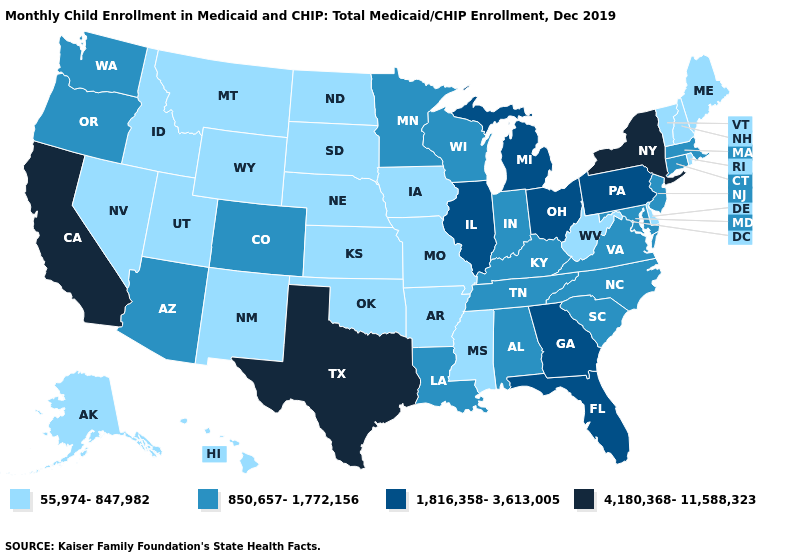Name the states that have a value in the range 4,180,368-11,588,323?
Quick response, please. California, New York, Texas. Which states have the highest value in the USA?
Short answer required. California, New York, Texas. Name the states that have a value in the range 1,816,358-3,613,005?
Quick response, please. Florida, Georgia, Illinois, Michigan, Ohio, Pennsylvania. Name the states that have a value in the range 4,180,368-11,588,323?
Give a very brief answer. California, New York, Texas. Among the states that border Utah , which have the lowest value?
Keep it brief. Idaho, Nevada, New Mexico, Wyoming. Name the states that have a value in the range 55,974-847,982?
Concise answer only. Alaska, Arkansas, Delaware, Hawaii, Idaho, Iowa, Kansas, Maine, Mississippi, Missouri, Montana, Nebraska, Nevada, New Hampshire, New Mexico, North Dakota, Oklahoma, Rhode Island, South Dakota, Utah, Vermont, West Virginia, Wyoming. Name the states that have a value in the range 4,180,368-11,588,323?
Answer briefly. California, New York, Texas. Does Georgia have the same value as Illinois?
Be succinct. Yes. What is the value of Nebraska?
Answer briefly. 55,974-847,982. Does the map have missing data?
Write a very short answer. No. Which states have the lowest value in the USA?
Short answer required. Alaska, Arkansas, Delaware, Hawaii, Idaho, Iowa, Kansas, Maine, Mississippi, Missouri, Montana, Nebraska, Nevada, New Hampshire, New Mexico, North Dakota, Oklahoma, Rhode Island, South Dakota, Utah, Vermont, West Virginia, Wyoming. Does Alabama have the highest value in the South?
Write a very short answer. No. Which states hav the highest value in the Northeast?
Write a very short answer. New York. Name the states that have a value in the range 850,657-1,772,156?
Short answer required. Alabama, Arizona, Colorado, Connecticut, Indiana, Kentucky, Louisiana, Maryland, Massachusetts, Minnesota, New Jersey, North Carolina, Oregon, South Carolina, Tennessee, Virginia, Washington, Wisconsin. What is the value of Kansas?
Give a very brief answer. 55,974-847,982. 